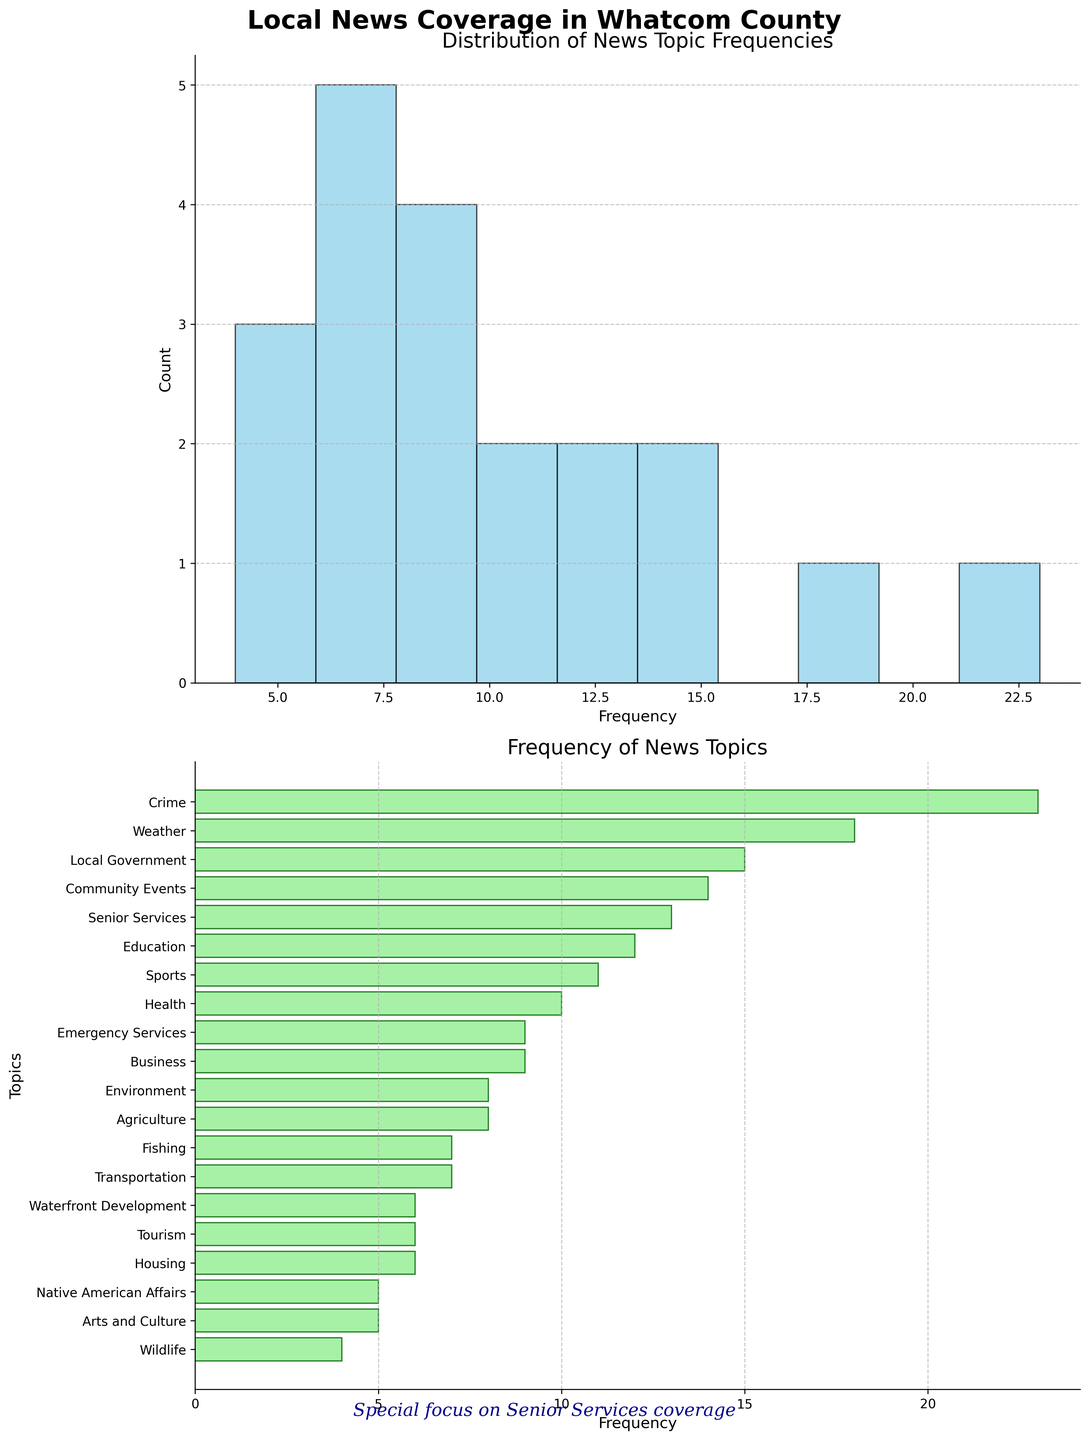What is the title of the figure? The title of the figure is located at the top and is clear, stating what the chart is about.
Answer: Local News Coverage in Whatcom County What is the most frequent news topic in Whatcom County media outlets? The most frequent topic is the one with the highest frequency bar in the histogram subplot and also the longest bar in the horizontal bar chart.
Answer: Crime How many news topics have a frequency greater than 10? By counting the topics in the horizontal bar chart whose bars extend beyond the value of 10 on the x-axis.
Answer: 7 Which topic appears less frequently: Health or Business? By comparing the lengths of the bars for Health and Business in the horizontal bar chart, we can see which one has a smaller value.
Answer: Business What is the range of frequencies in the histogram? The range of frequencies can be determined by finding the difference between the highest and lowest values in the histogram.
Answer: 4 to 23 What is the median frequency of the news topics? First, arrange the frequencies in ascending order and find the middle value, or average the two middle values if necessary.
Answer: 8 How does the frequency distribution of the topics look in the histogram subplot? By observing the shape of the histogram bars, notice if the distribution is skewed, uniform, or has other notable features.
Answer: Slightly left-skewed Which topics have a frequency of 6? Find the bars that align with the frequency value of 6 in the horizontal bar chart to identify these topics.
Answer: Housing, Tourism, and Waterfront Development In which frequency bin does the majority of the topics lie in the histogram? Count the number of topics that fall into each bin and identify the bin with the highest count.
Answer: 5-7 What's the average frequency of all the news topics? Sum all the frequencies and divide by the number of topics to find the average frequency.
Answer: 10 